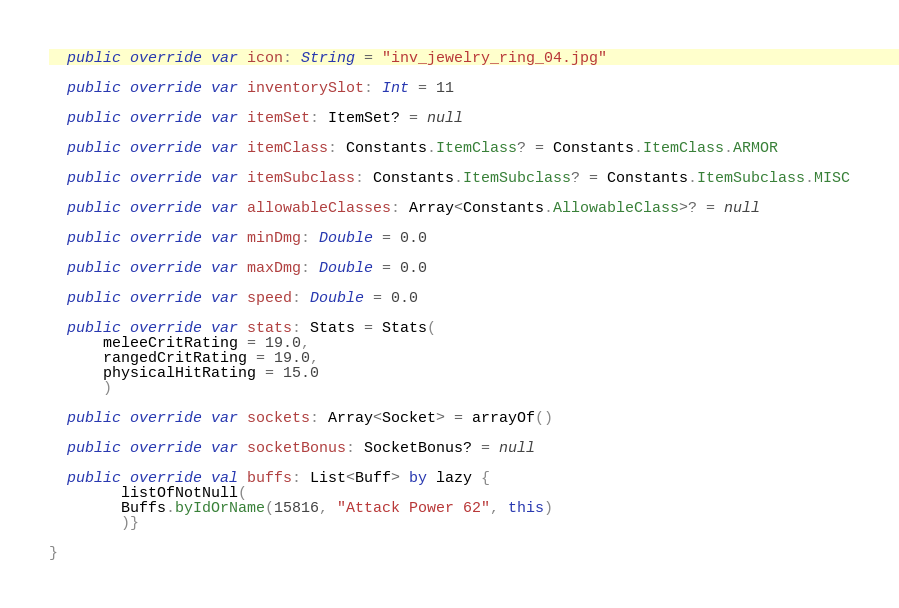<code> <loc_0><loc_0><loc_500><loc_500><_Kotlin_>
  public override var icon: String = "inv_jewelry_ring_04.jpg"

  public override var inventorySlot: Int = 11

  public override var itemSet: ItemSet? = null

  public override var itemClass: Constants.ItemClass? = Constants.ItemClass.ARMOR

  public override var itemSubclass: Constants.ItemSubclass? = Constants.ItemSubclass.MISC

  public override var allowableClasses: Array<Constants.AllowableClass>? = null

  public override var minDmg: Double = 0.0

  public override var maxDmg: Double = 0.0

  public override var speed: Double = 0.0

  public override var stats: Stats = Stats(
      meleeCritRating = 19.0,
      rangedCritRating = 19.0,
      physicalHitRating = 15.0
      )

  public override var sockets: Array<Socket> = arrayOf()

  public override var socketBonus: SocketBonus? = null

  public override val buffs: List<Buff> by lazy {
        listOfNotNull(
        Buffs.byIdOrName(15816, "Attack Power 62", this)
        )}

}
</code> 